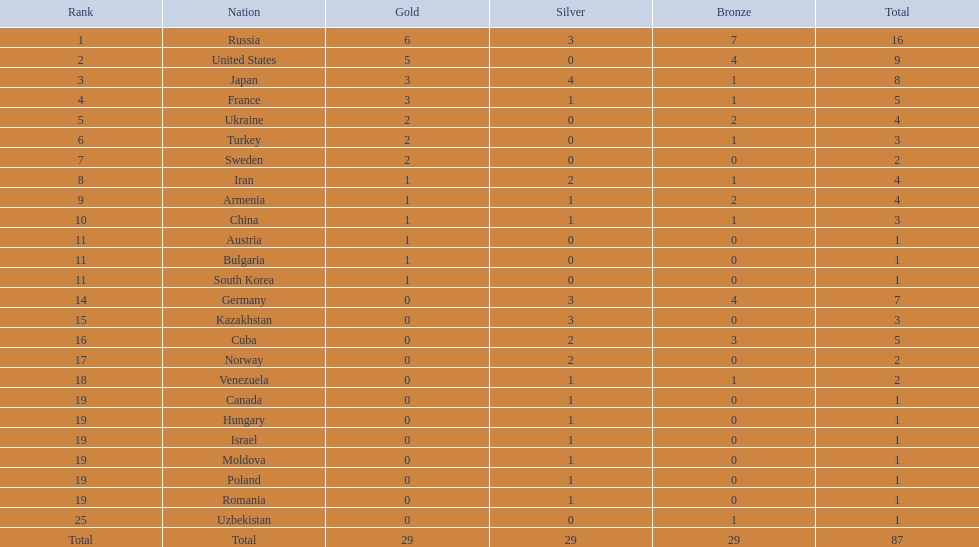What are the various nations? Russia, 6, United States, 5, Japan, 3, France, 3, Ukraine, 2, Turkey, 2, Sweden, 2, Iran, 1, Armenia, 1, China, 1, Austria, 1, Bulgaria, 1, South Korea, 1, Germany, 0, Kazakhstan, 0, Cuba, 0, Norway, 0, Venezuela, 0, Canada, 0, Hungary, 0, Israel, 0, Moldova, 0, Poland, 0, Romania, 0, Uzbekistan, 0. Which countries have secured gold? Russia, 6, United States, 5, Japan, 3, France, 3, Ukraine, 2, Turkey, 2, Sweden, 2, Iran, 1, Armenia, 1, China, 1, Austria, 1, Bulgaria, 1, South Korea, 1. How many gold medals has the united states achieved? United States, 5. Which nation has over 5 gold medals? Russia, 6. Which nation is being referred to? Russia. 